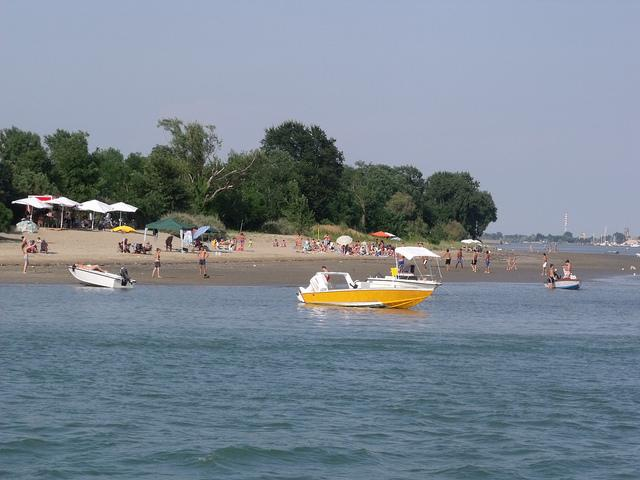What energy moves these boats? Please explain your reasoning. electricity. The motors being used are traditional dc wound motors that propel the boat forward. 